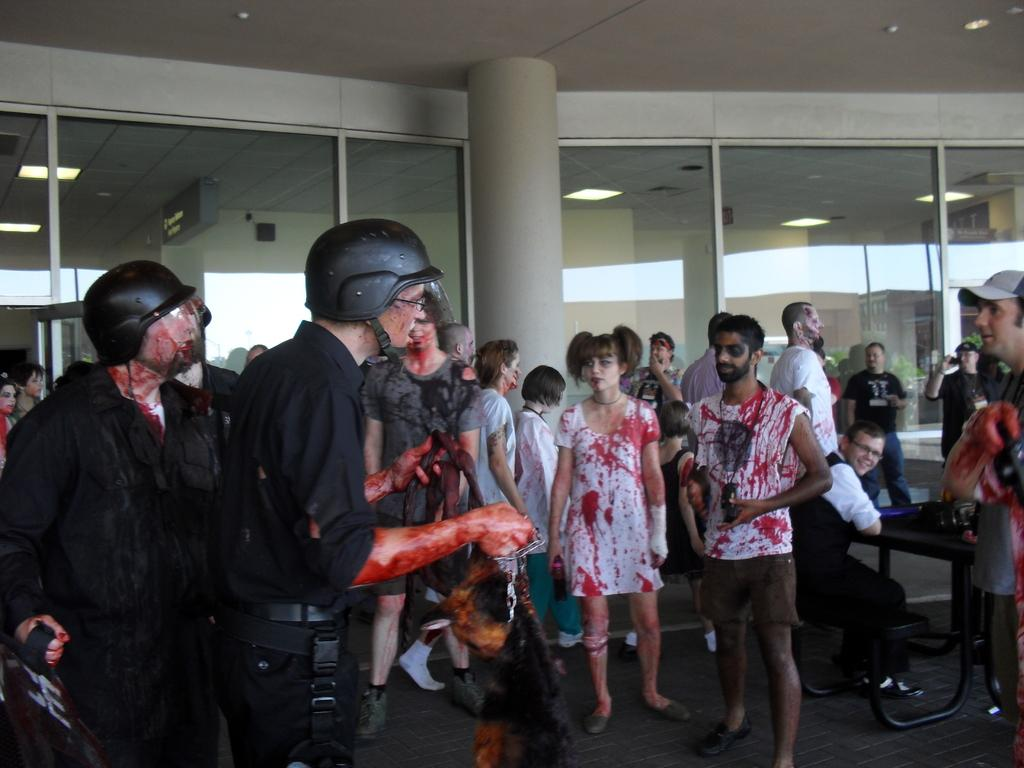What are the people in the image doing? The people in the image are standing on the floor. What is located on the right side of the image? There is a table on the right side of the image. Can you describe the seating arrangement in the image? There is a person sitting on a bench beside the table. What can be seen in the background of the image? There is a building in the background. What type of silver is being used by the expert in the image? There is no expert or silver present in the image. Is there a hole in the floor where the people are standing? There is no hole visible in the floor where the people are standing. 